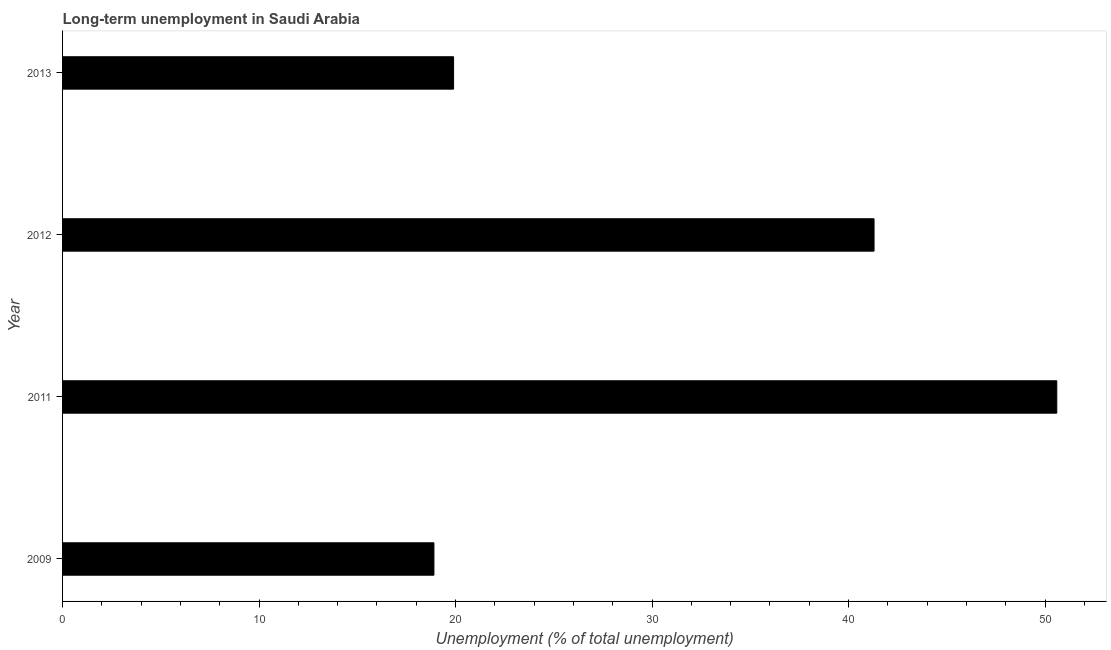Does the graph contain any zero values?
Your answer should be very brief. No. What is the title of the graph?
Offer a very short reply. Long-term unemployment in Saudi Arabia. What is the label or title of the X-axis?
Your response must be concise. Unemployment (% of total unemployment). What is the label or title of the Y-axis?
Offer a very short reply. Year. What is the long-term unemployment in 2013?
Give a very brief answer. 19.9. Across all years, what is the maximum long-term unemployment?
Your answer should be compact. 50.6. Across all years, what is the minimum long-term unemployment?
Provide a succinct answer. 18.9. In which year was the long-term unemployment maximum?
Your answer should be very brief. 2011. What is the sum of the long-term unemployment?
Provide a short and direct response. 130.7. What is the difference between the long-term unemployment in 2009 and 2011?
Offer a terse response. -31.7. What is the average long-term unemployment per year?
Offer a very short reply. 32.67. What is the median long-term unemployment?
Offer a very short reply. 30.6. What is the ratio of the long-term unemployment in 2009 to that in 2012?
Ensure brevity in your answer.  0.46. Is the long-term unemployment in 2009 less than that in 2012?
Your answer should be compact. Yes. Is the difference between the long-term unemployment in 2012 and 2013 greater than the difference between any two years?
Your answer should be compact. No. What is the difference between the highest and the second highest long-term unemployment?
Offer a terse response. 9.3. What is the difference between the highest and the lowest long-term unemployment?
Make the answer very short. 31.7. In how many years, is the long-term unemployment greater than the average long-term unemployment taken over all years?
Make the answer very short. 2. Are all the bars in the graph horizontal?
Make the answer very short. Yes. Are the values on the major ticks of X-axis written in scientific E-notation?
Keep it short and to the point. No. What is the Unemployment (% of total unemployment) of 2009?
Give a very brief answer. 18.9. What is the Unemployment (% of total unemployment) in 2011?
Offer a very short reply. 50.6. What is the Unemployment (% of total unemployment) of 2012?
Offer a very short reply. 41.3. What is the Unemployment (% of total unemployment) of 2013?
Your answer should be very brief. 19.9. What is the difference between the Unemployment (% of total unemployment) in 2009 and 2011?
Provide a short and direct response. -31.7. What is the difference between the Unemployment (% of total unemployment) in 2009 and 2012?
Your answer should be very brief. -22.4. What is the difference between the Unemployment (% of total unemployment) in 2009 and 2013?
Make the answer very short. -1. What is the difference between the Unemployment (% of total unemployment) in 2011 and 2013?
Your response must be concise. 30.7. What is the difference between the Unemployment (% of total unemployment) in 2012 and 2013?
Your response must be concise. 21.4. What is the ratio of the Unemployment (% of total unemployment) in 2009 to that in 2011?
Provide a short and direct response. 0.37. What is the ratio of the Unemployment (% of total unemployment) in 2009 to that in 2012?
Give a very brief answer. 0.46. What is the ratio of the Unemployment (% of total unemployment) in 2009 to that in 2013?
Give a very brief answer. 0.95. What is the ratio of the Unemployment (% of total unemployment) in 2011 to that in 2012?
Give a very brief answer. 1.23. What is the ratio of the Unemployment (% of total unemployment) in 2011 to that in 2013?
Your response must be concise. 2.54. What is the ratio of the Unemployment (% of total unemployment) in 2012 to that in 2013?
Your answer should be very brief. 2.08. 